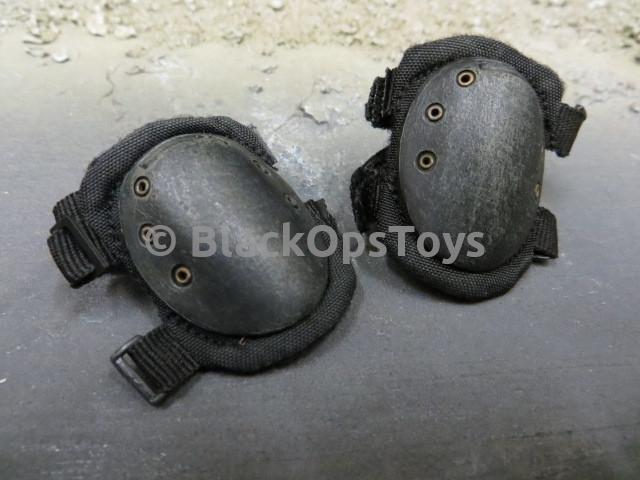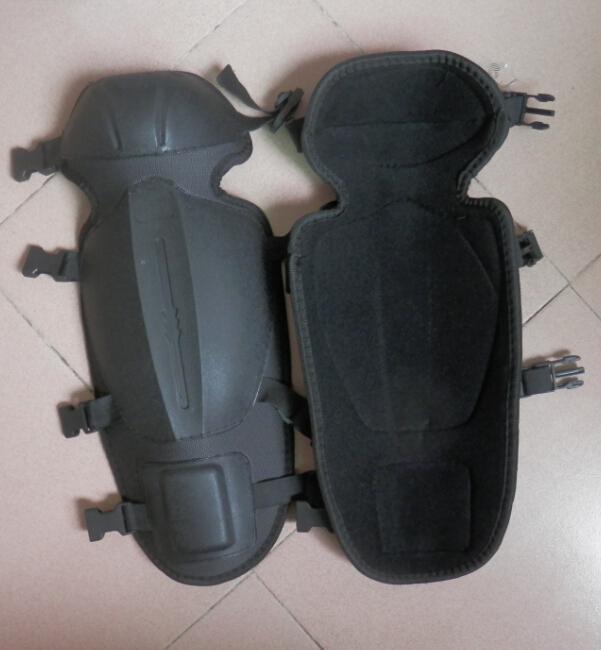The first image is the image on the left, the second image is the image on the right. Considering the images on both sides, is "The right image contains exactly two pairs of black pads arranged with one pair above the other." valid? Answer yes or no. No. The first image is the image on the left, the second image is the image on the right. Evaluate the accuracy of this statement regarding the images: "Some knee pads have a camouflage design.". Is it true? Answer yes or no. No. 